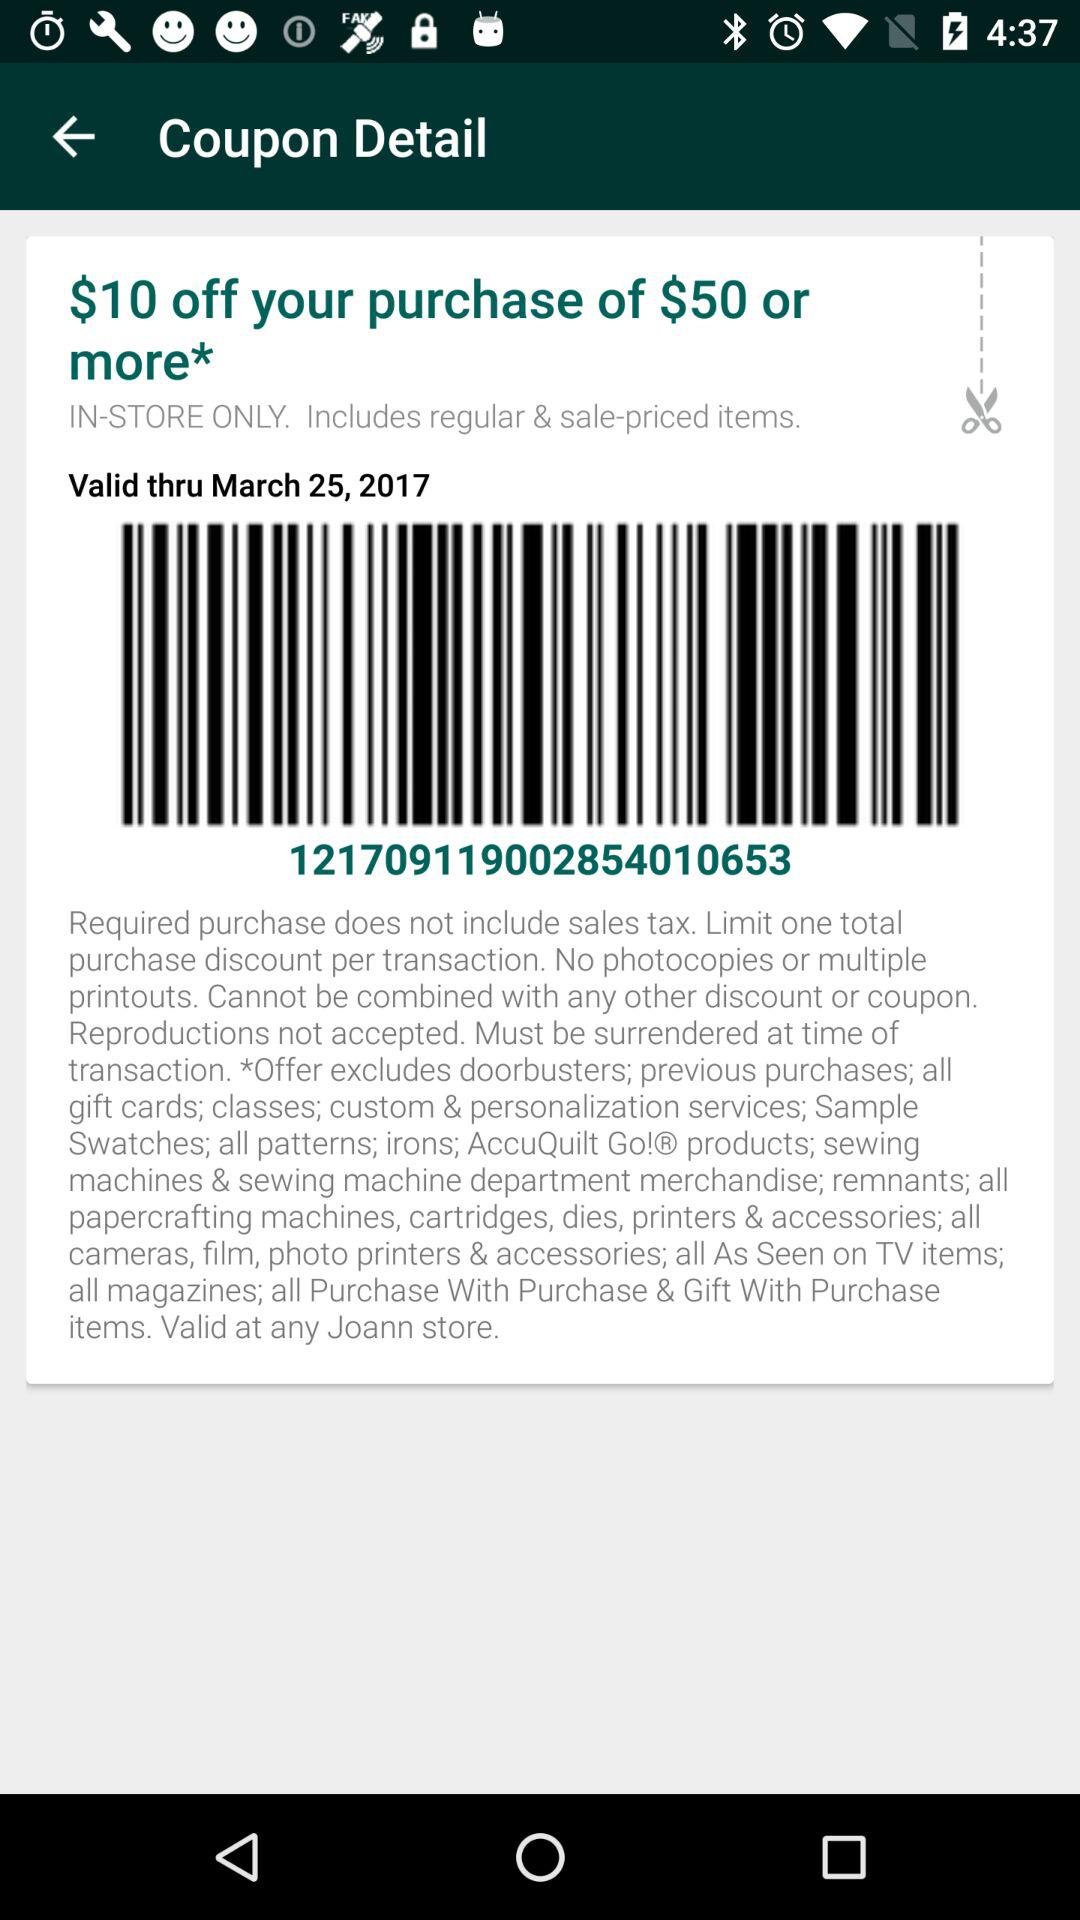What is the minimum purchase amount required to use this coupon?
Answer the question using a single word or phrase. $50 